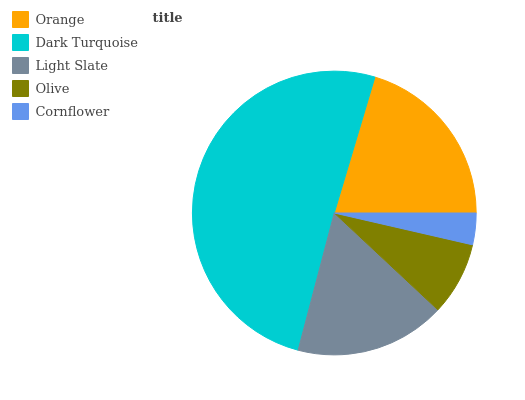Is Cornflower the minimum?
Answer yes or no. Yes. Is Dark Turquoise the maximum?
Answer yes or no. Yes. Is Light Slate the minimum?
Answer yes or no. No. Is Light Slate the maximum?
Answer yes or no. No. Is Dark Turquoise greater than Light Slate?
Answer yes or no. Yes. Is Light Slate less than Dark Turquoise?
Answer yes or no. Yes. Is Light Slate greater than Dark Turquoise?
Answer yes or no. No. Is Dark Turquoise less than Light Slate?
Answer yes or no. No. Is Light Slate the high median?
Answer yes or no. Yes. Is Light Slate the low median?
Answer yes or no. Yes. Is Olive the high median?
Answer yes or no. No. Is Cornflower the low median?
Answer yes or no. No. 